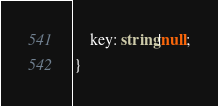<code> <loc_0><loc_0><loc_500><loc_500><_TypeScript_>    key: string|null;
}
</code> 